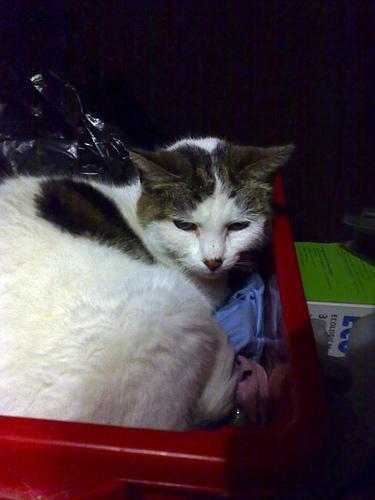How many cats are there?
Give a very brief answer. 1. 